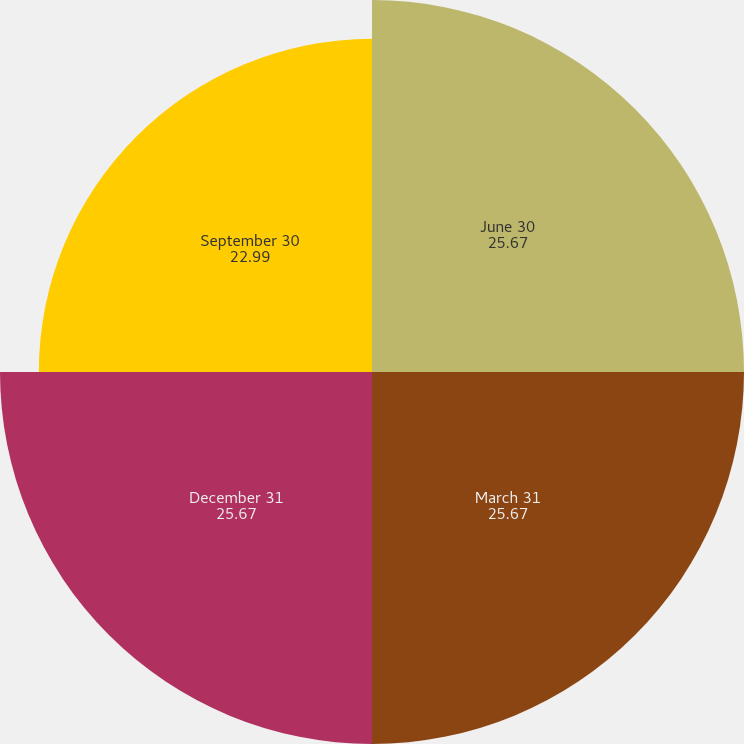Convert chart to OTSL. <chart><loc_0><loc_0><loc_500><loc_500><pie_chart><fcel>June 30<fcel>March 31<fcel>December 31<fcel>September 30<nl><fcel>25.67%<fcel>25.67%<fcel>25.67%<fcel>22.99%<nl></chart> 